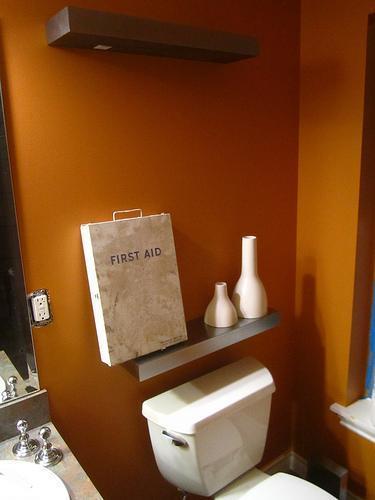How many vases are in the picture?
Give a very brief answer. 2. 